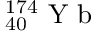Convert formula to latex. <formula><loc_0><loc_0><loc_500><loc_500>_ { 4 0 } ^ { 1 7 4 } Y b</formula> 